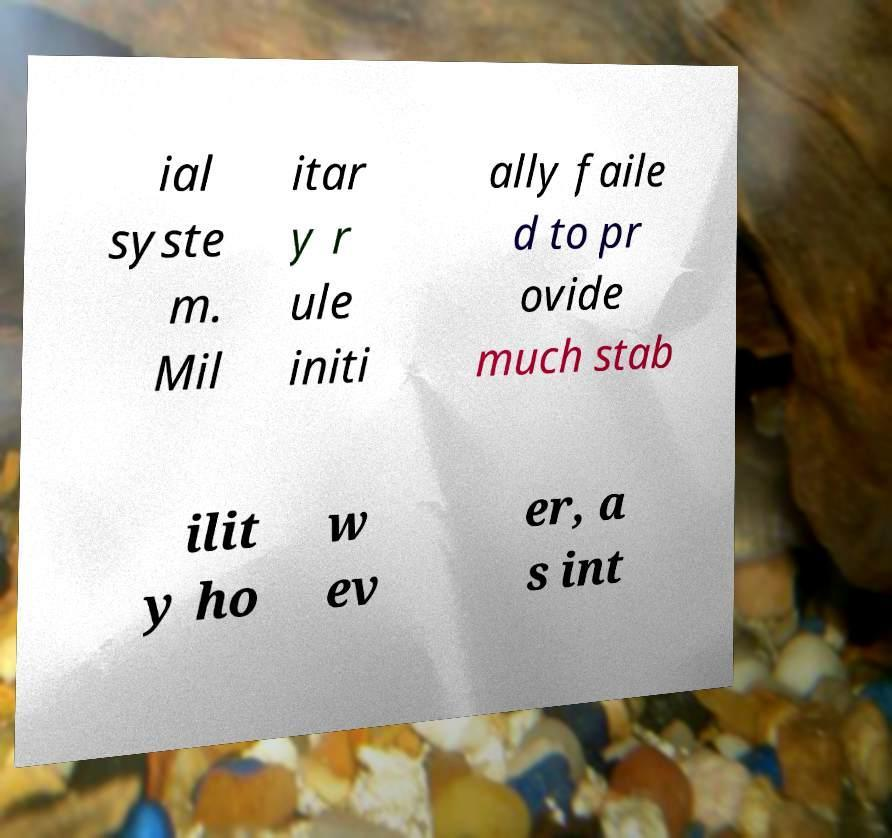I need the written content from this picture converted into text. Can you do that? ial syste m. Mil itar y r ule initi ally faile d to pr ovide much stab ilit y ho w ev er, a s int 